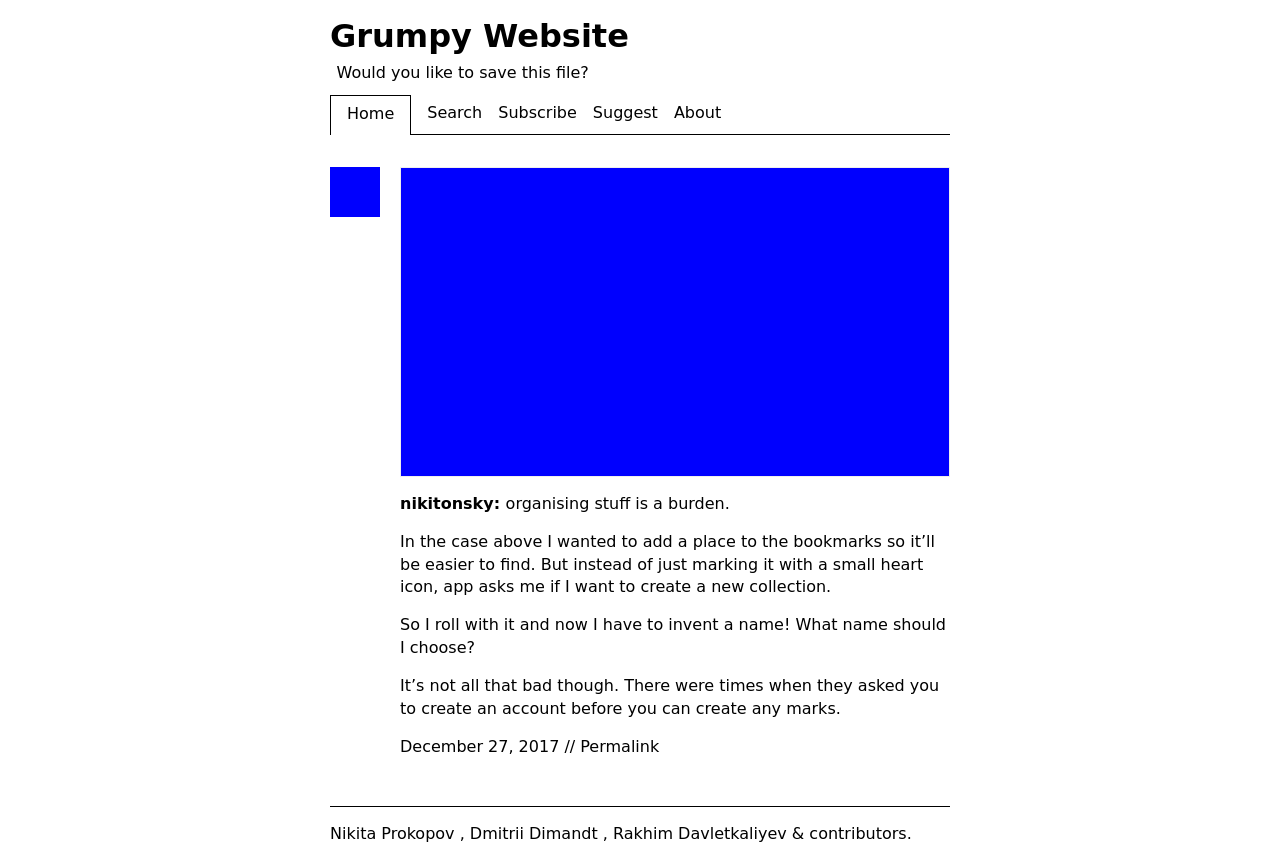What can you infer about the brand or individual behind the website based on the design and content? Based on the design and content showing in the image of the website, it appears to represent an individual or brand that values minimalism and straightforward communication. The title 'Grumpy Website' suggests a theme of candid critique or commentary, likely on web design or user experience topics. The straightforward text-based content indicates a focus on written communication rather than multimedia. 